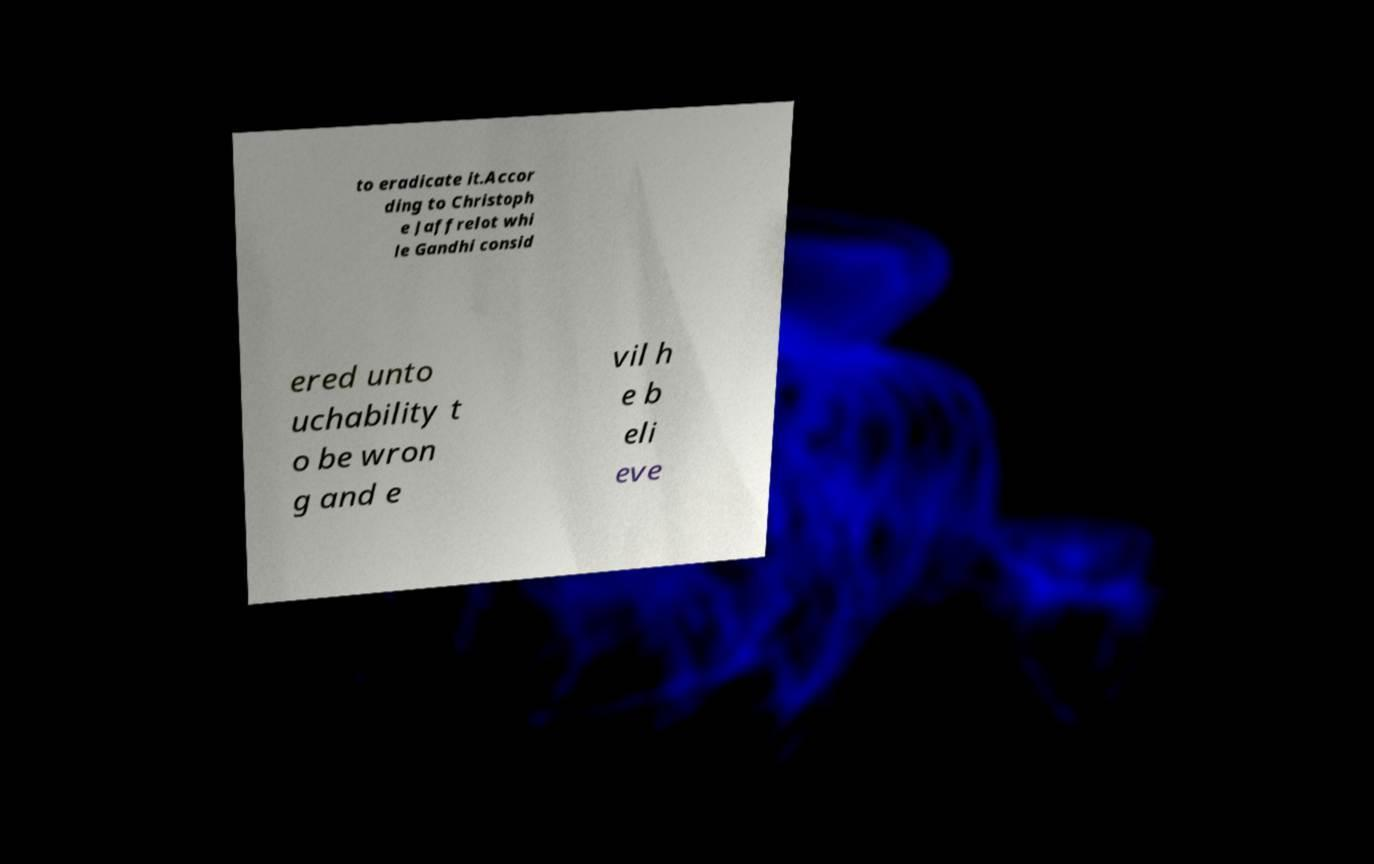What messages or text are displayed in this image? I need them in a readable, typed format. to eradicate it.Accor ding to Christoph e Jaffrelot whi le Gandhi consid ered unto uchability t o be wron g and e vil h e b eli eve 